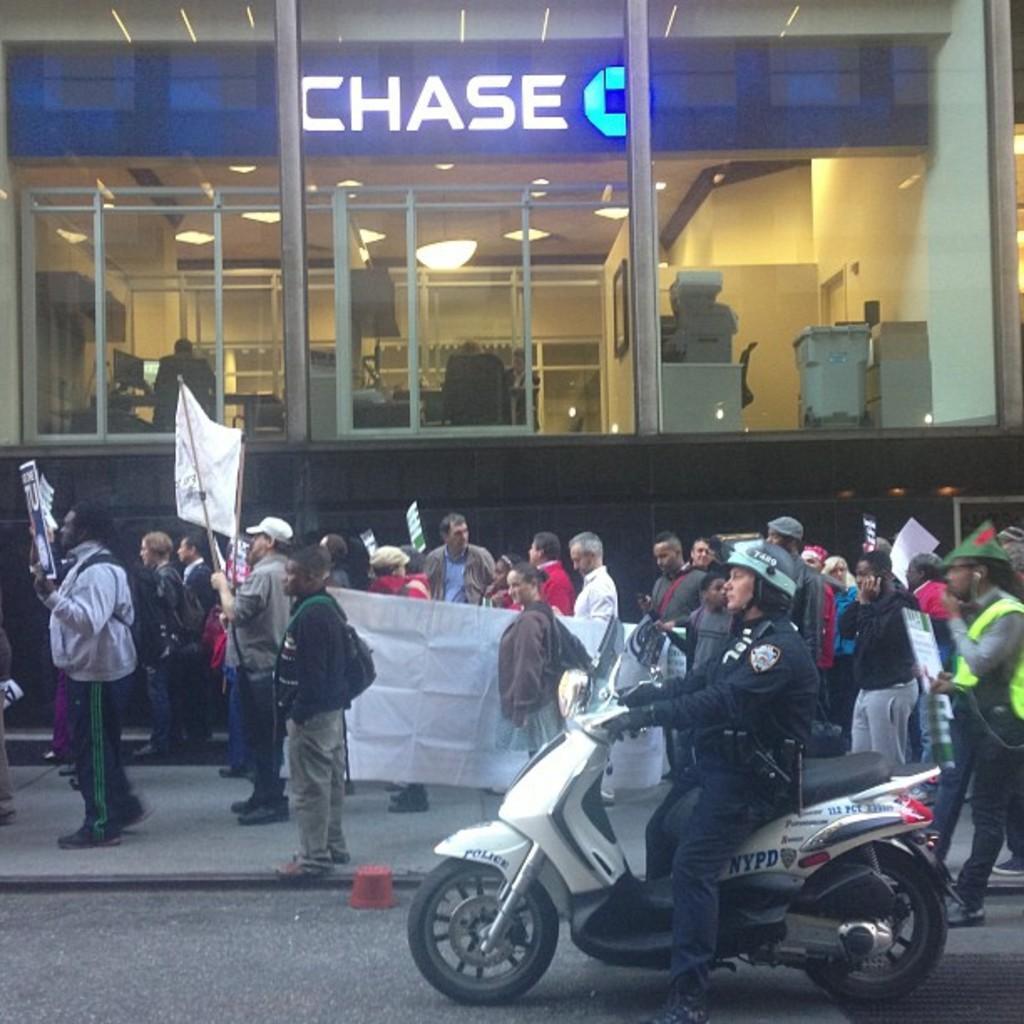Describe this image in one or two sentences. In this picture I can see there are few people walking on the way and they are holding a few banners and there is a person riding the two wheeler. There is a building in the backdrop and it has glass doors and there are few people and lights visible from the glass. 